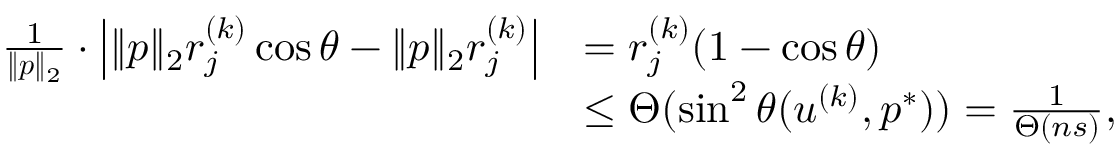<formula> <loc_0><loc_0><loc_500><loc_500>\begin{array} { r l } { \frac { 1 } { \| { \boldsymbol p } \| _ { 2 } } \cdot \left | \| { \boldsymbol p } \| _ { 2 } r _ { j } ^ { ( k ) } \cos \theta - \| { \boldsymbol p } \| _ { 2 } r _ { j } ^ { ( k ) } \right | } & { = r _ { j } ^ { ( k ) } ( 1 - \cos \theta ) } \\ & { \leq \Theta ( \sin ^ { 2 } \theta ( { \boldsymbol u } ^ { ( k ) } , { \boldsymbol p } ^ { * } ) ) = \frac { 1 } { \Theta \left ( n s \right ) } , } \end{array}</formula> 